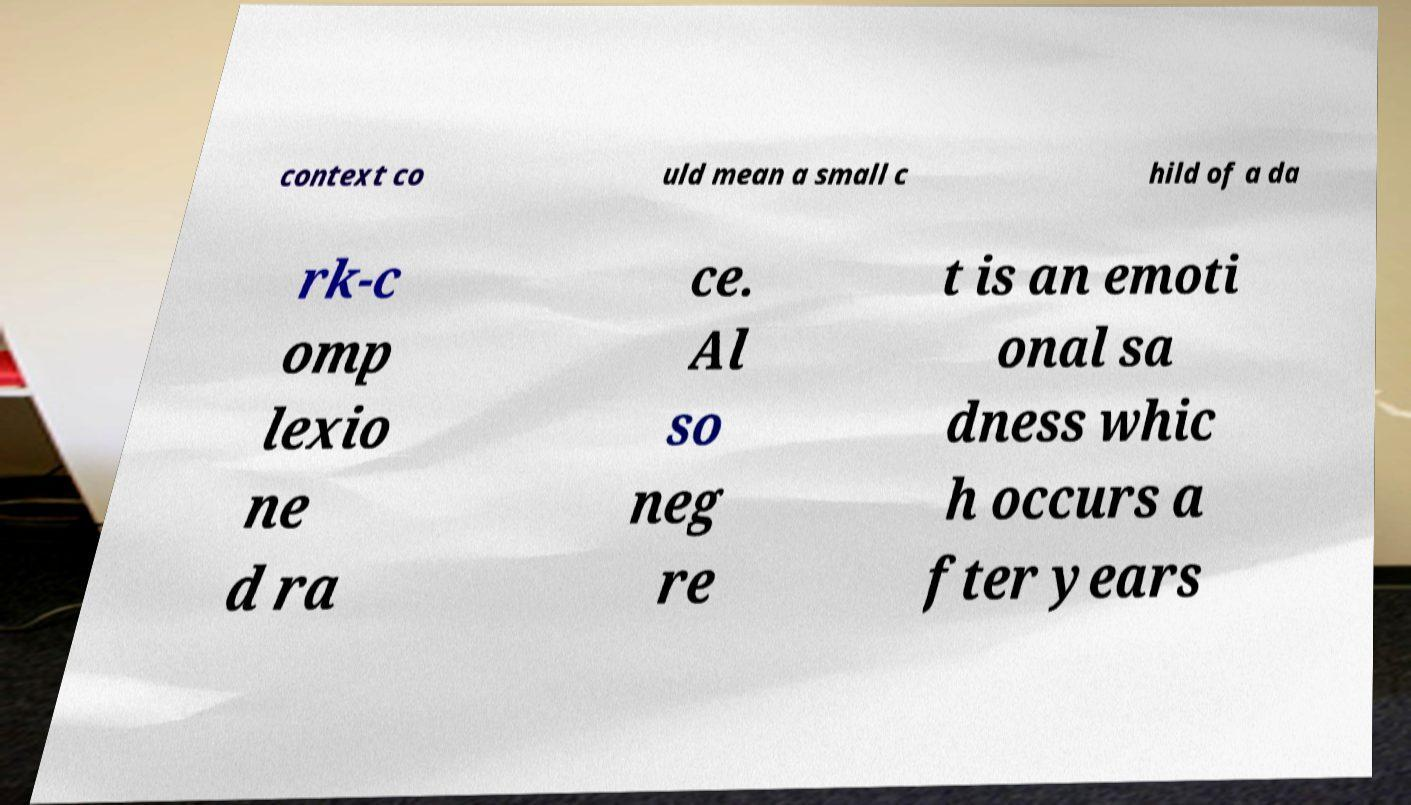Can you read and provide the text displayed in the image?This photo seems to have some interesting text. Can you extract and type it out for me? context co uld mean a small c hild of a da rk-c omp lexio ne d ra ce. Al so neg re t is an emoti onal sa dness whic h occurs a fter years 